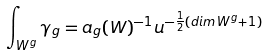<formula> <loc_0><loc_0><loc_500><loc_500>\int _ { W ^ { g } } \gamma _ { g } = a _ { g } ( W ) ^ { - 1 } u ^ { - \frac { 1 } { 2 } ( d i m \, W ^ { g } + 1 ) }</formula> 